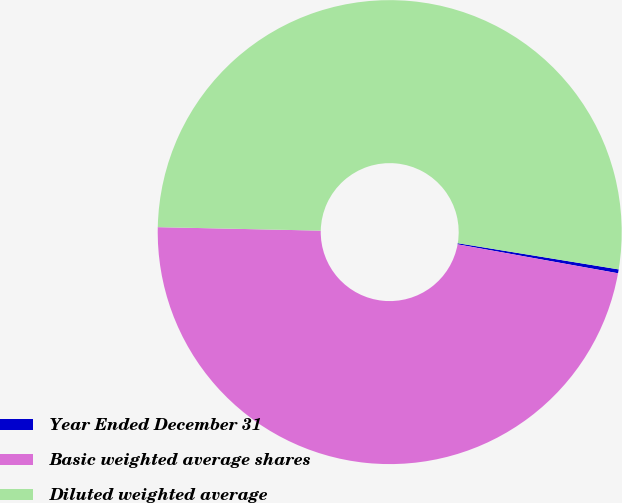Convert chart. <chart><loc_0><loc_0><loc_500><loc_500><pie_chart><fcel>Year Ended December 31<fcel>Basic weighted average shares<fcel>Diluted weighted average<nl><fcel>0.27%<fcel>47.5%<fcel>52.23%<nl></chart> 